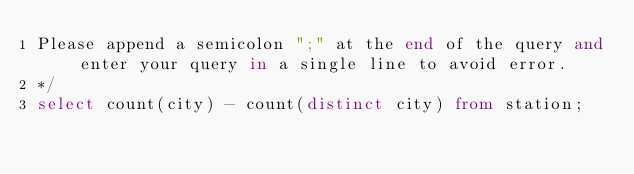Convert code to text. <code><loc_0><loc_0><loc_500><loc_500><_SQL_>Please append a semicolon ";" at the end of the query and enter your query in a single line to avoid error.
*/
select count(city) - count(distinct city) from station;
</code> 